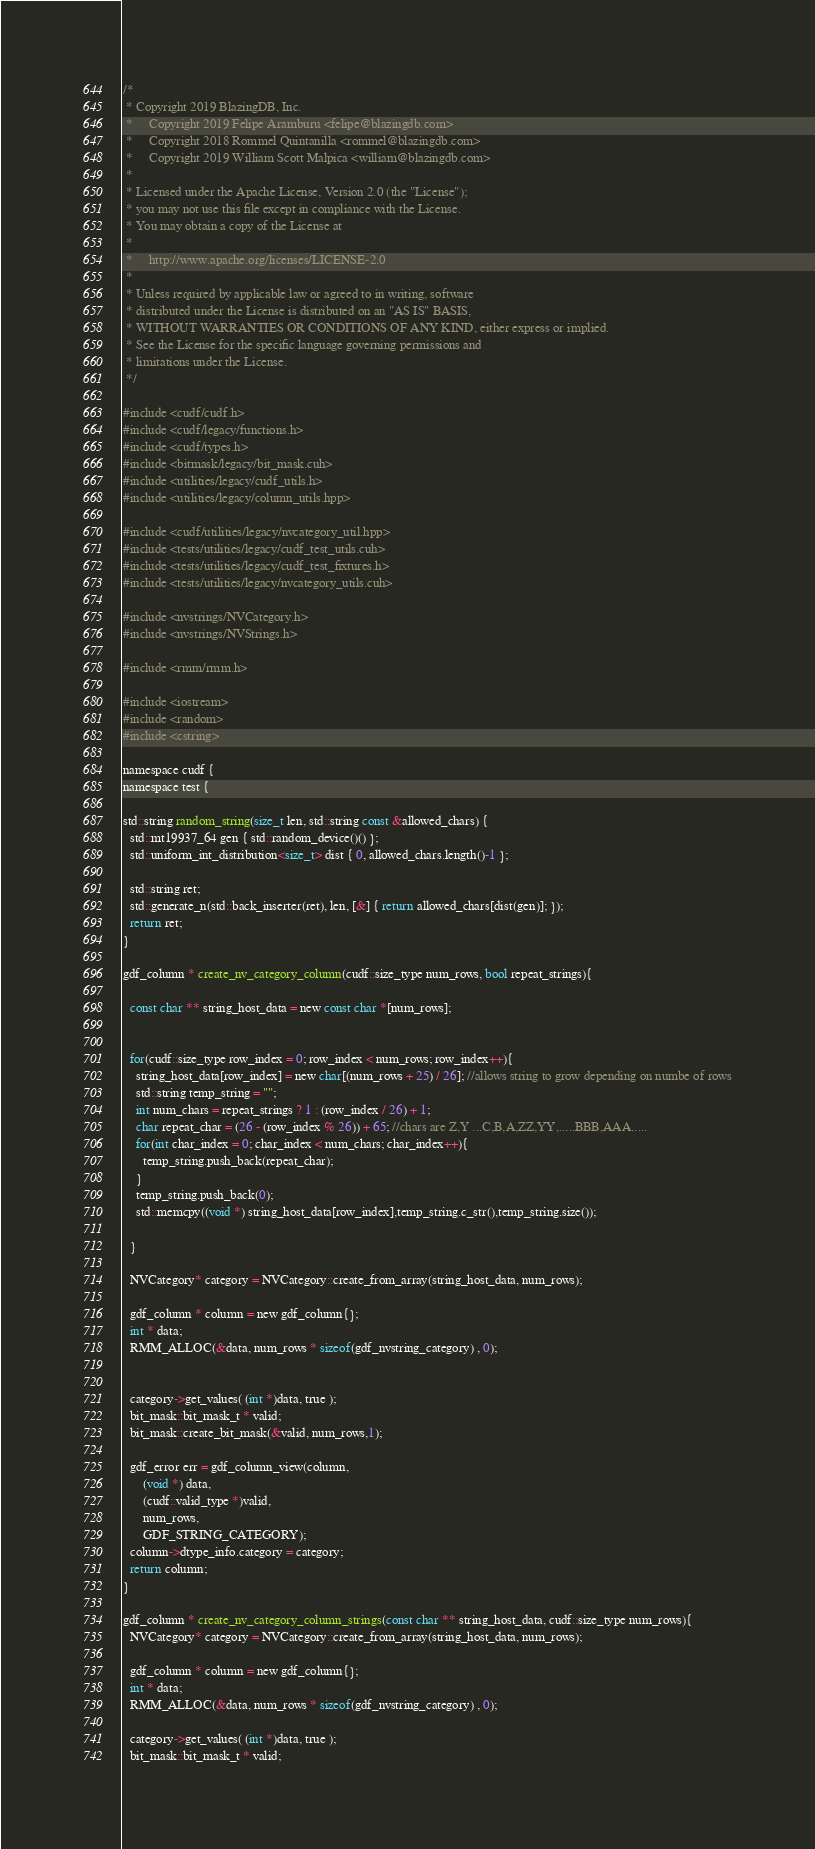Convert code to text. <code><loc_0><loc_0><loc_500><loc_500><_Cuda_>/*
 * Copyright 2019 BlazingDB, Inc.
 *     Copyright 2019 Felipe Aramburu <felipe@blazingdb.com>
 *     Copyright 2018 Rommel Quintanilla <rommel@blazingdb.com>
 *     Copyright 2019 William Scott Malpica <william@blazingdb.com>
 *
 * Licensed under the Apache License, Version 2.0 (the "License");
 * you may not use this file except in compliance with the License.
 * You may obtain a copy of the License at
 *
 *     http://www.apache.org/licenses/LICENSE-2.0
 *
 * Unless required by applicable law or agreed to in writing, software
 * distributed under the License is distributed on an "AS IS" BASIS,
 * WITHOUT WARRANTIES OR CONDITIONS OF ANY KIND, either express or implied.
 * See the License for the specific language governing permissions and
 * limitations under the License.
 */

#include <cudf/cudf.h>
#include <cudf/legacy/functions.h>
#include <cudf/types.h>
#include <bitmask/legacy/bit_mask.cuh>
#include <utilities/legacy/cudf_utils.h>
#include <utilities/legacy/column_utils.hpp>

#include <cudf/utilities/legacy/nvcategory_util.hpp>
#include <tests/utilities/legacy/cudf_test_utils.cuh>
#include <tests/utilities/legacy/cudf_test_fixtures.h>
#include <tests/utilities/legacy/nvcategory_utils.cuh>

#include <nvstrings/NVCategory.h>
#include <nvstrings/NVStrings.h>

#include <rmm/rmm.h>

#include <iostream>
#include <random>
#include <cstring>

namespace cudf {
namespace test {

std::string random_string(size_t len, std::string const &allowed_chars) {
  std::mt19937_64 gen { std::random_device()() };
  std::uniform_int_distribution<size_t> dist { 0, allowed_chars.length()-1 };

  std::string ret;
  std::generate_n(std::back_inserter(ret), len, [&] { return allowed_chars[dist(gen)]; });
  return ret;
}

gdf_column * create_nv_category_column(cudf::size_type num_rows, bool repeat_strings){

  const char ** string_host_data = new const char *[num_rows];


  for(cudf::size_type row_index = 0; row_index < num_rows; row_index++){
    string_host_data[row_index] = new char[(num_rows + 25) / 26]; //allows string to grow depending on numbe of rows
    std::string temp_string = "";
    int num_chars = repeat_strings ? 1 : (row_index / 26) + 1;
    char repeat_char = (26 - (row_index % 26)) + 65; //chars are Z,Y ...C,B,A,ZZ,YY,.....BBB,AAA.....
    for(int char_index = 0; char_index < num_chars; char_index++){
      temp_string.push_back(repeat_char);
    }
    temp_string.push_back(0);
    std::memcpy((void *) string_host_data[row_index],temp_string.c_str(),temp_string.size());

  }

  NVCategory* category = NVCategory::create_from_array(string_host_data, num_rows);

  gdf_column * column = new gdf_column{};
  int * data;
  RMM_ALLOC(&data, num_rows * sizeof(gdf_nvstring_category) , 0);


  category->get_values( (int *)data, true );
  bit_mask::bit_mask_t * valid;
  bit_mask::create_bit_mask(&valid, num_rows,1);

  gdf_error err = gdf_column_view(column,
      (void *) data,
      (cudf::valid_type *)valid,
      num_rows,
      GDF_STRING_CATEGORY);
  column->dtype_info.category = category;
  return column;
}

gdf_column * create_nv_category_column_strings(const char ** string_host_data, cudf::size_type num_rows){
  NVCategory* category = NVCategory::create_from_array(string_host_data, num_rows);

  gdf_column * column = new gdf_column{};
  int * data;
  RMM_ALLOC(&data, num_rows * sizeof(gdf_nvstring_category) , 0);

  category->get_values( (int *)data, true );
  bit_mask::bit_mask_t * valid;</code> 